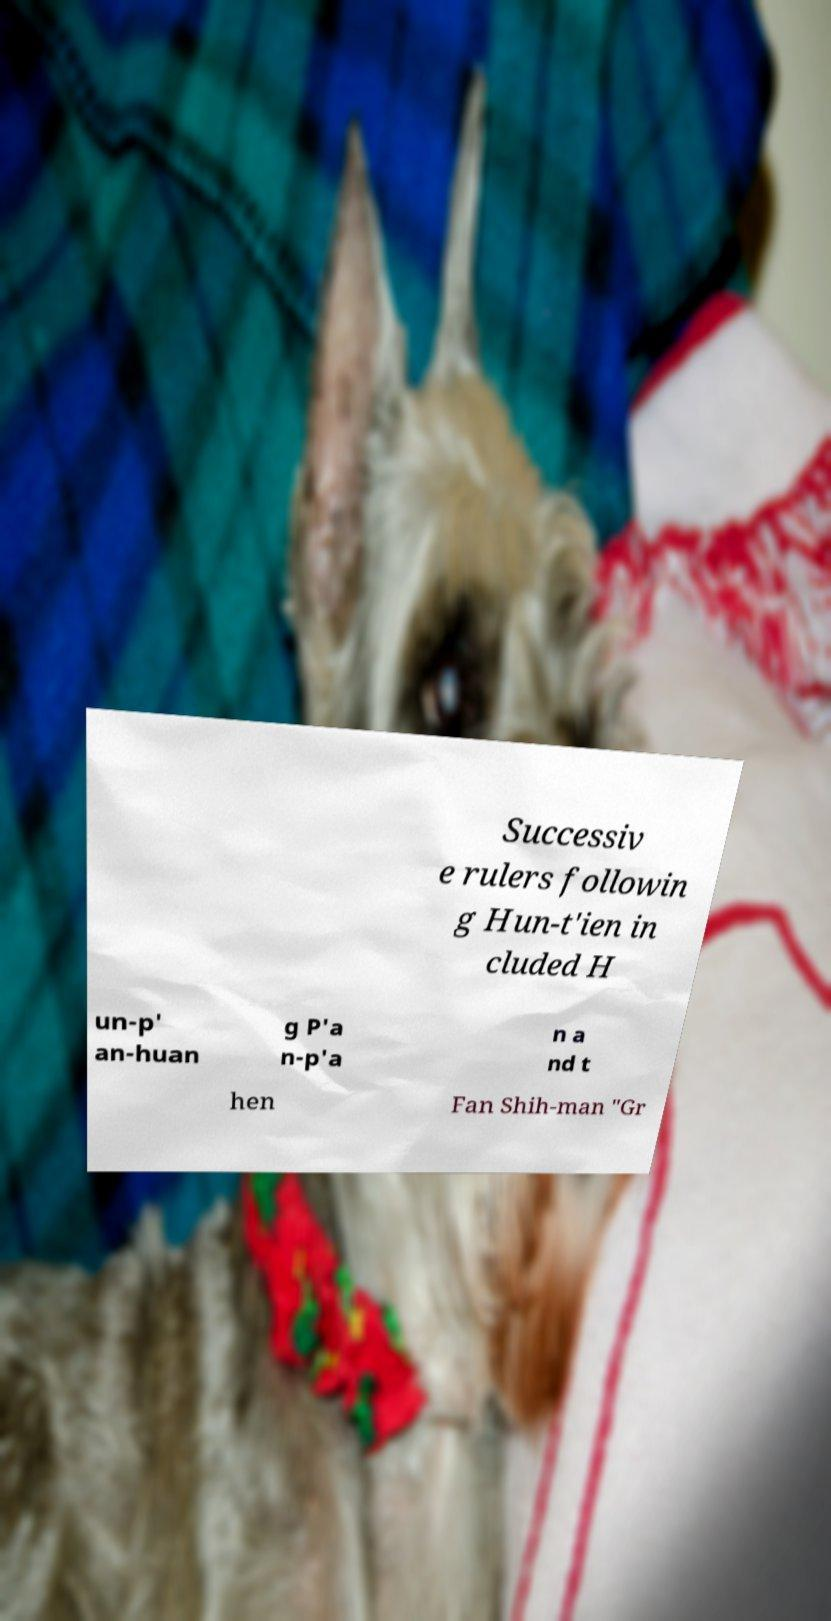For documentation purposes, I need the text within this image transcribed. Could you provide that? Successiv e rulers followin g Hun-t'ien in cluded H un-p' an-huan g P'a n-p'a n a nd t hen Fan Shih-man "Gr 